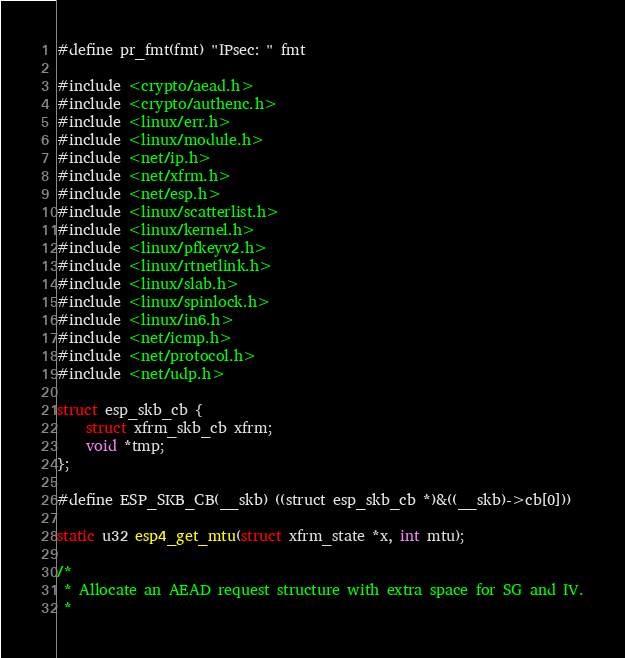<code> <loc_0><loc_0><loc_500><loc_500><_C_>#define pr_fmt(fmt) "IPsec: " fmt

#include <crypto/aead.h>
#include <crypto/authenc.h>
#include <linux/err.h>
#include <linux/module.h>
#include <net/ip.h>
#include <net/xfrm.h>
#include <net/esp.h>
#include <linux/scatterlist.h>
#include <linux/kernel.h>
#include <linux/pfkeyv2.h>
#include <linux/rtnetlink.h>
#include <linux/slab.h>
#include <linux/spinlock.h>
#include <linux/in6.h>
#include <net/icmp.h>
#include <net/protocol.h>
#include <net/udp.h>

struct esp_skb_cb {
	struct xfrm_skb_cb xfrm;
	void *tmp;
};

#define ESP_SKB_CB(__skb) ((struct esp_skb_cb *)&((__skb)->cb[0]))

static u32 esp4_get_mtu(struct xfrm_state *x, int mtu);

/*
 * Allocate an AEAD request structure with extra space for SG and IV.
 *</code> 